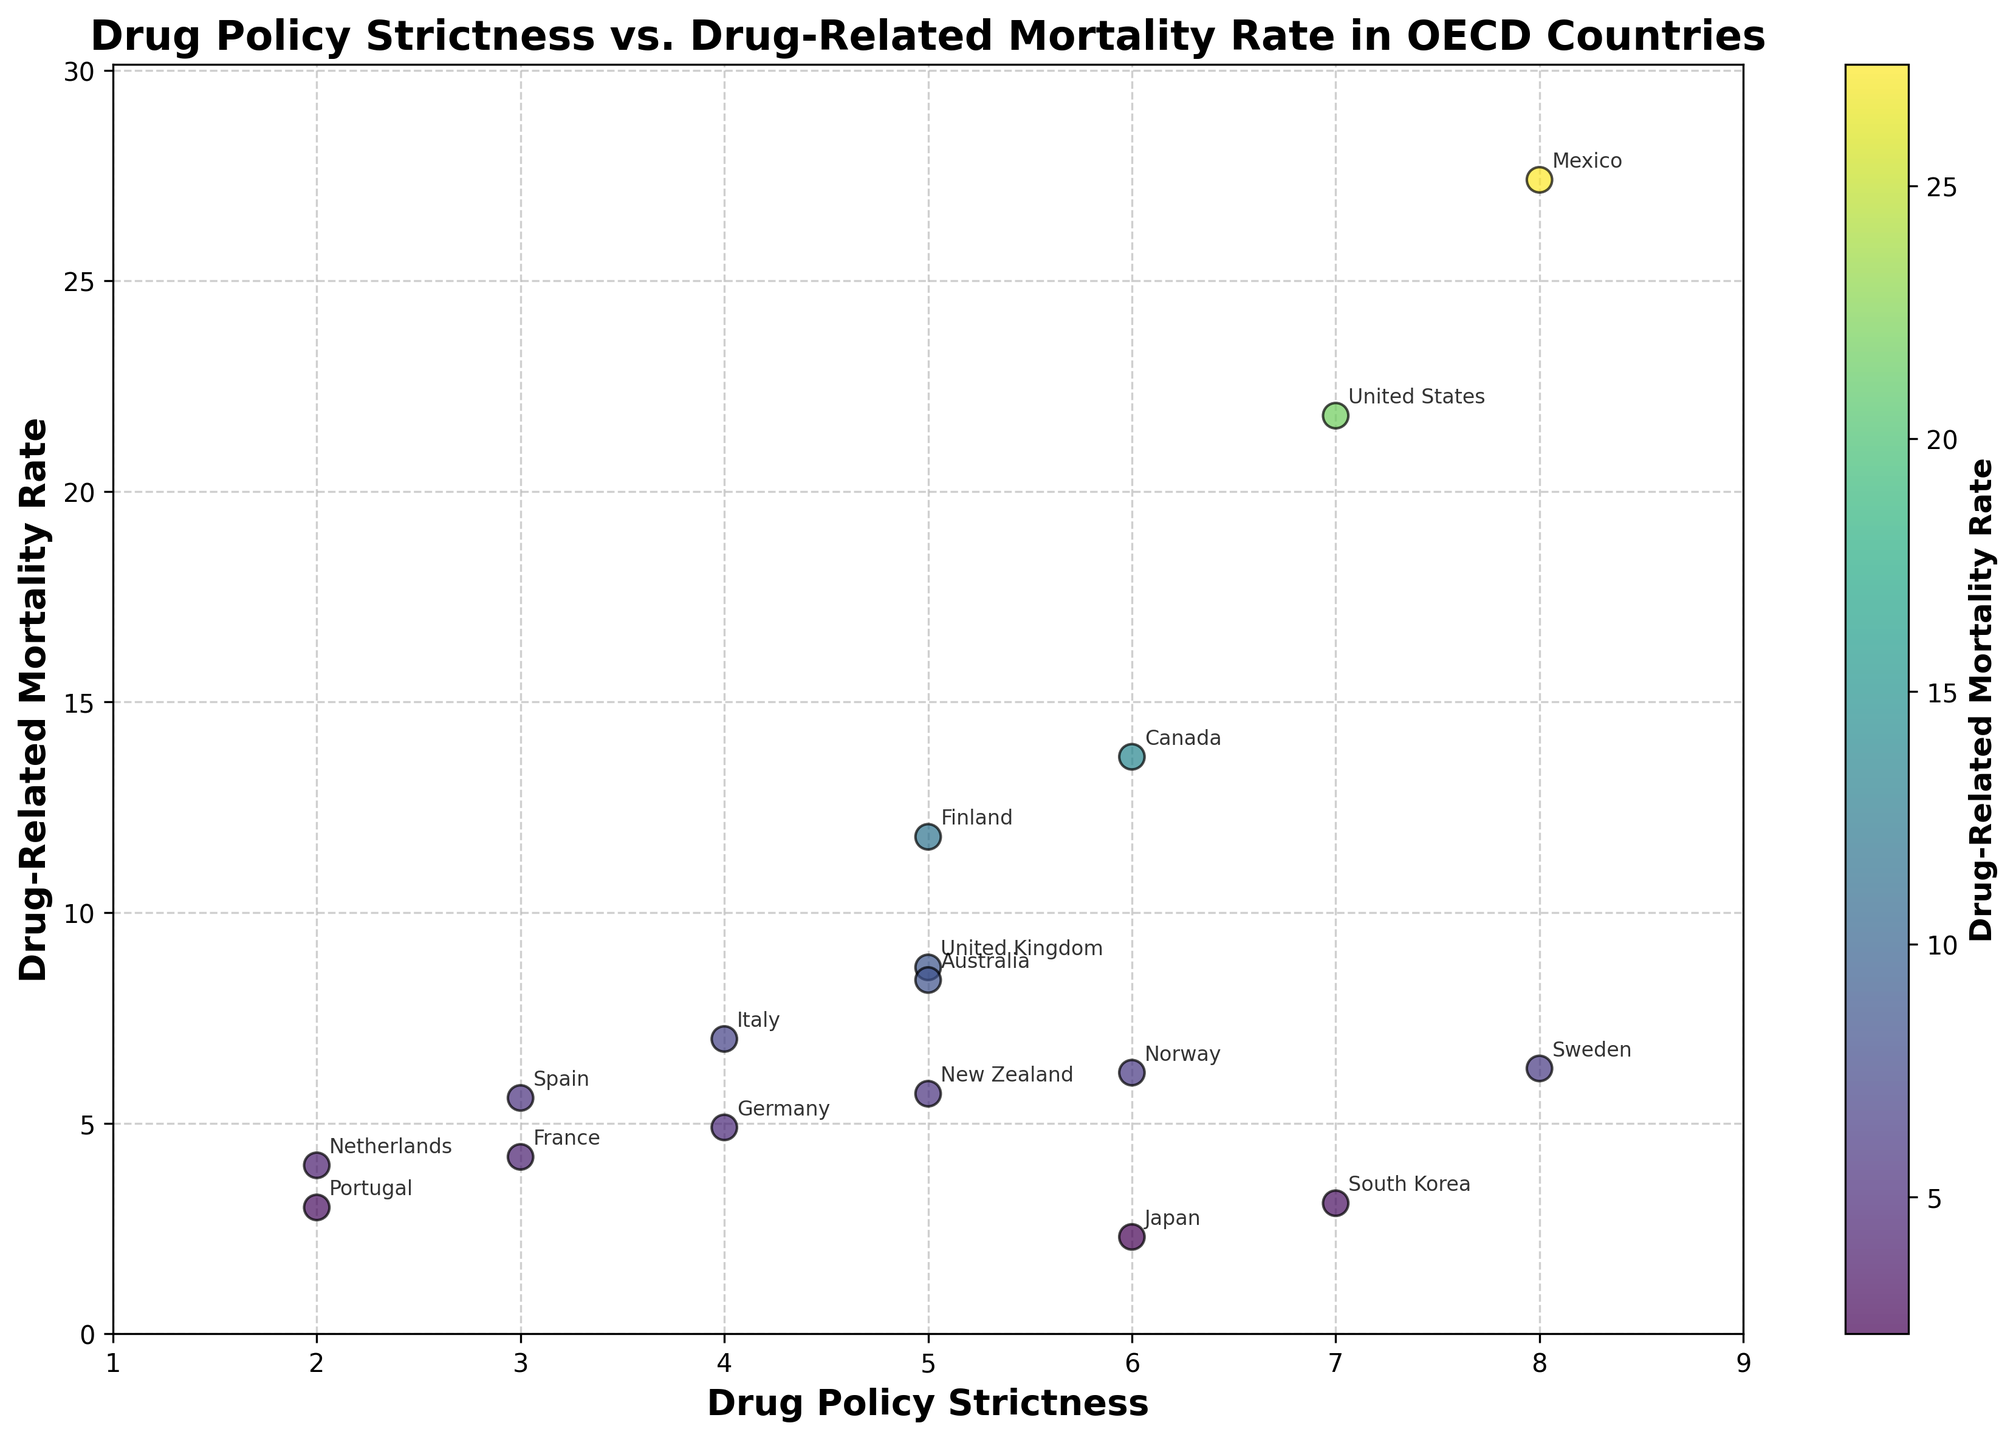What's the title of the scatter plot? The title is prominently displayed at the top of the figure in bold text and provides a summary of what the figure is about.
Answer: Drug Policy Strictness vs. Drug-Related Mortality Rate in OECD Countries How many data points are there in the scatter plot? Each country listed in the data set corresponds to one data point in the scatter plot. By counting the number of countries, we get the total number of data points.
Answer: 17 Which country has the highest drug-related mortality rate? By looking at the y-axis, we identify the country with the highest point on the plot.
Answer: Mexico What's the range of drug policy strictness values shown on the x-axis? The x-axis shows the range of drug policy strictness values from the minimum to the maximum.
Answer: 1 to 9 Which country has the lowest drug-related mortality rate and what is its value? By identifying the lowest point on the y-axis, we can see which country it corresponds to and its exact value.
Answer: Japan, 2.3 What is the average drug-related mortality rate for countries with a drug policy strictness of 5? Identify the countries with a strictness value of 5, then calculate the average of their mortality rates. Countries: United Kingdom (8.7), Australia (8.4), Finland (11.8), New Zealand (5.7). Average = (8.7 + 8.4 + 11.8 + 5.7) / 4 = 8.65
Answer: 8.65 Which country has the strictest drug policy and how does its drug-related mortality rate compare to the least strict country? Identify the country with the highest drug policy strictness value (8) and compare its mortality rate to the country with the lowest strictness value (2). Most strict: Mexico (27.4). Least strict: Portugal (3.0) and Netherlands (4.0).
Answer: Mexico has a much higher rate compared to both Portugal and Netherlands Is there more variability among countries with lower or higher drug policy strictness? Assess the spread of the y-values (mortality rates) for countries with low versus high x-values (strictness). There appears to be more spread and higher values in the stricter policy group.
Answer: Higher drug policy strictness 